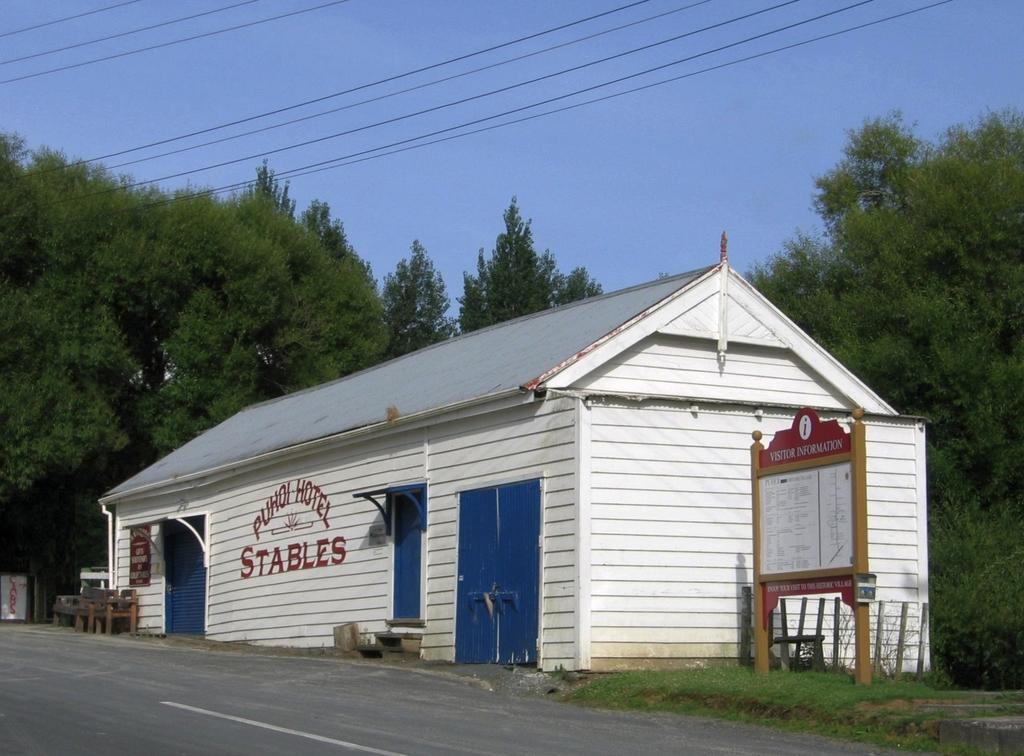Could you give a brief overview of what you see in this image? In the foreground I can see stable house, board, grass and chairs on the road. In the background I can see trees. On the top I can see the sky and wires. This image is taken during a day. 